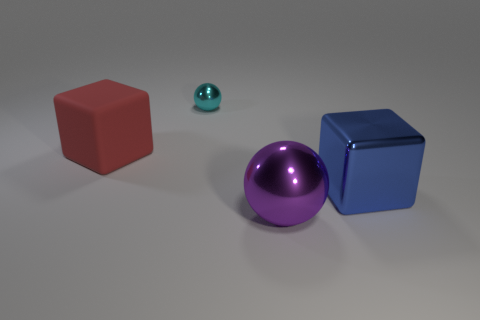What could be the possible use of these objects in the image? The objects could serve various purposes, such as educational tools for teaching geometry and colors, elements in a computer graphics rendering exercise, or simply decorative items. 